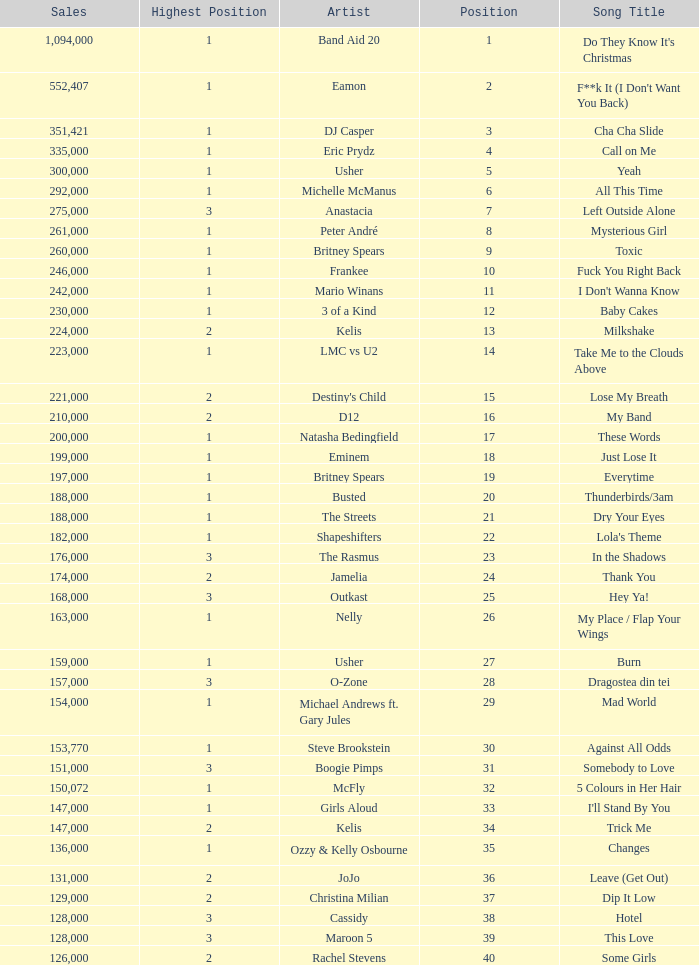What is the most sales by a song with a position higher than 3? None. 